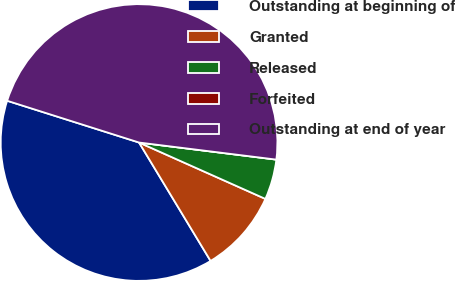Convert chart to OTSL. <chart><loc_0><loc_0><loc_500><loc_500><pie_chart><fcel>Outstanding at beginning of<fcel>Granted<fcel>Released<fcel>Forfeited<fcel>Outstanding at end of year<nl><fcel>38.53%<fcel>9.67%<fcel>4.71%<fcel>0.0%<fcel>47.09%<nl></chart> 